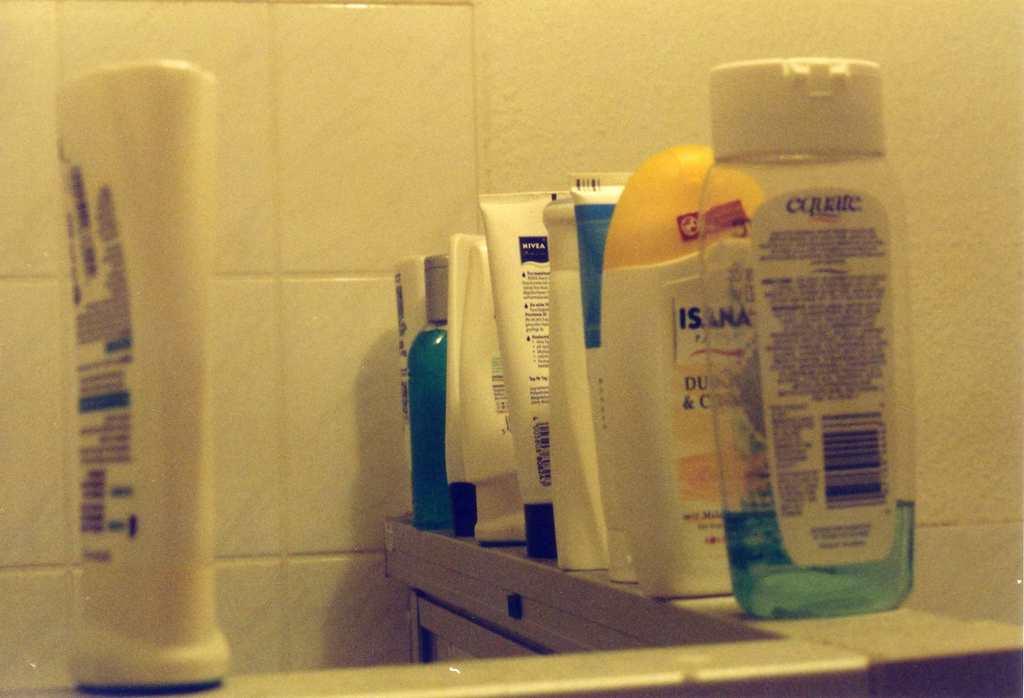What brand of product is in the nearest clear bottle?
Ensure brevity in your answer.  Equate. What company name is at the top of the white label?
Give a very brief answer. Equate. 